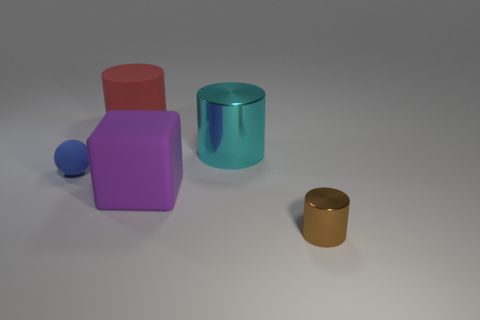The cylinder that is the same material as the blue thing is what color? The cylinder sharing the same reflective, metallic material qualities as the smaller blue sphere is gold in color. 